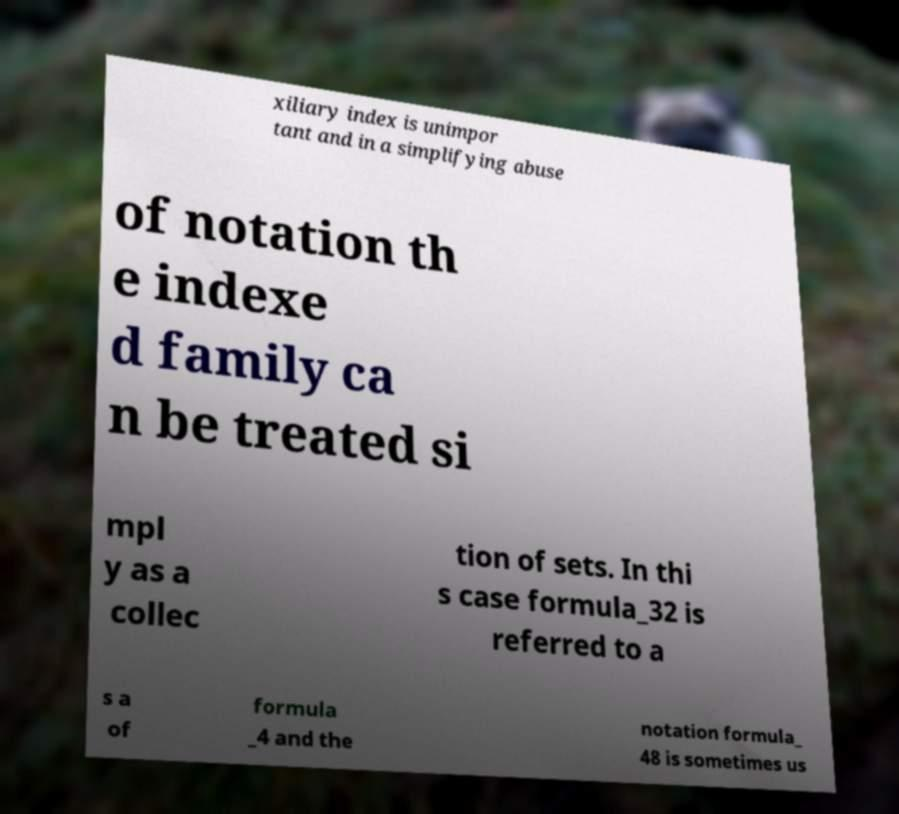For documentation purposes, I need the text within this image transcribed. Could you provide that? xiliary index is unimpor tant and in a simplifying abuse of notation th e indexe d family ca n be treated si mpl y as a collec tion of sets. In thi s case formula_32 is referred to a s a of formula _4 and the notation formula_ 48 is sometimes us 